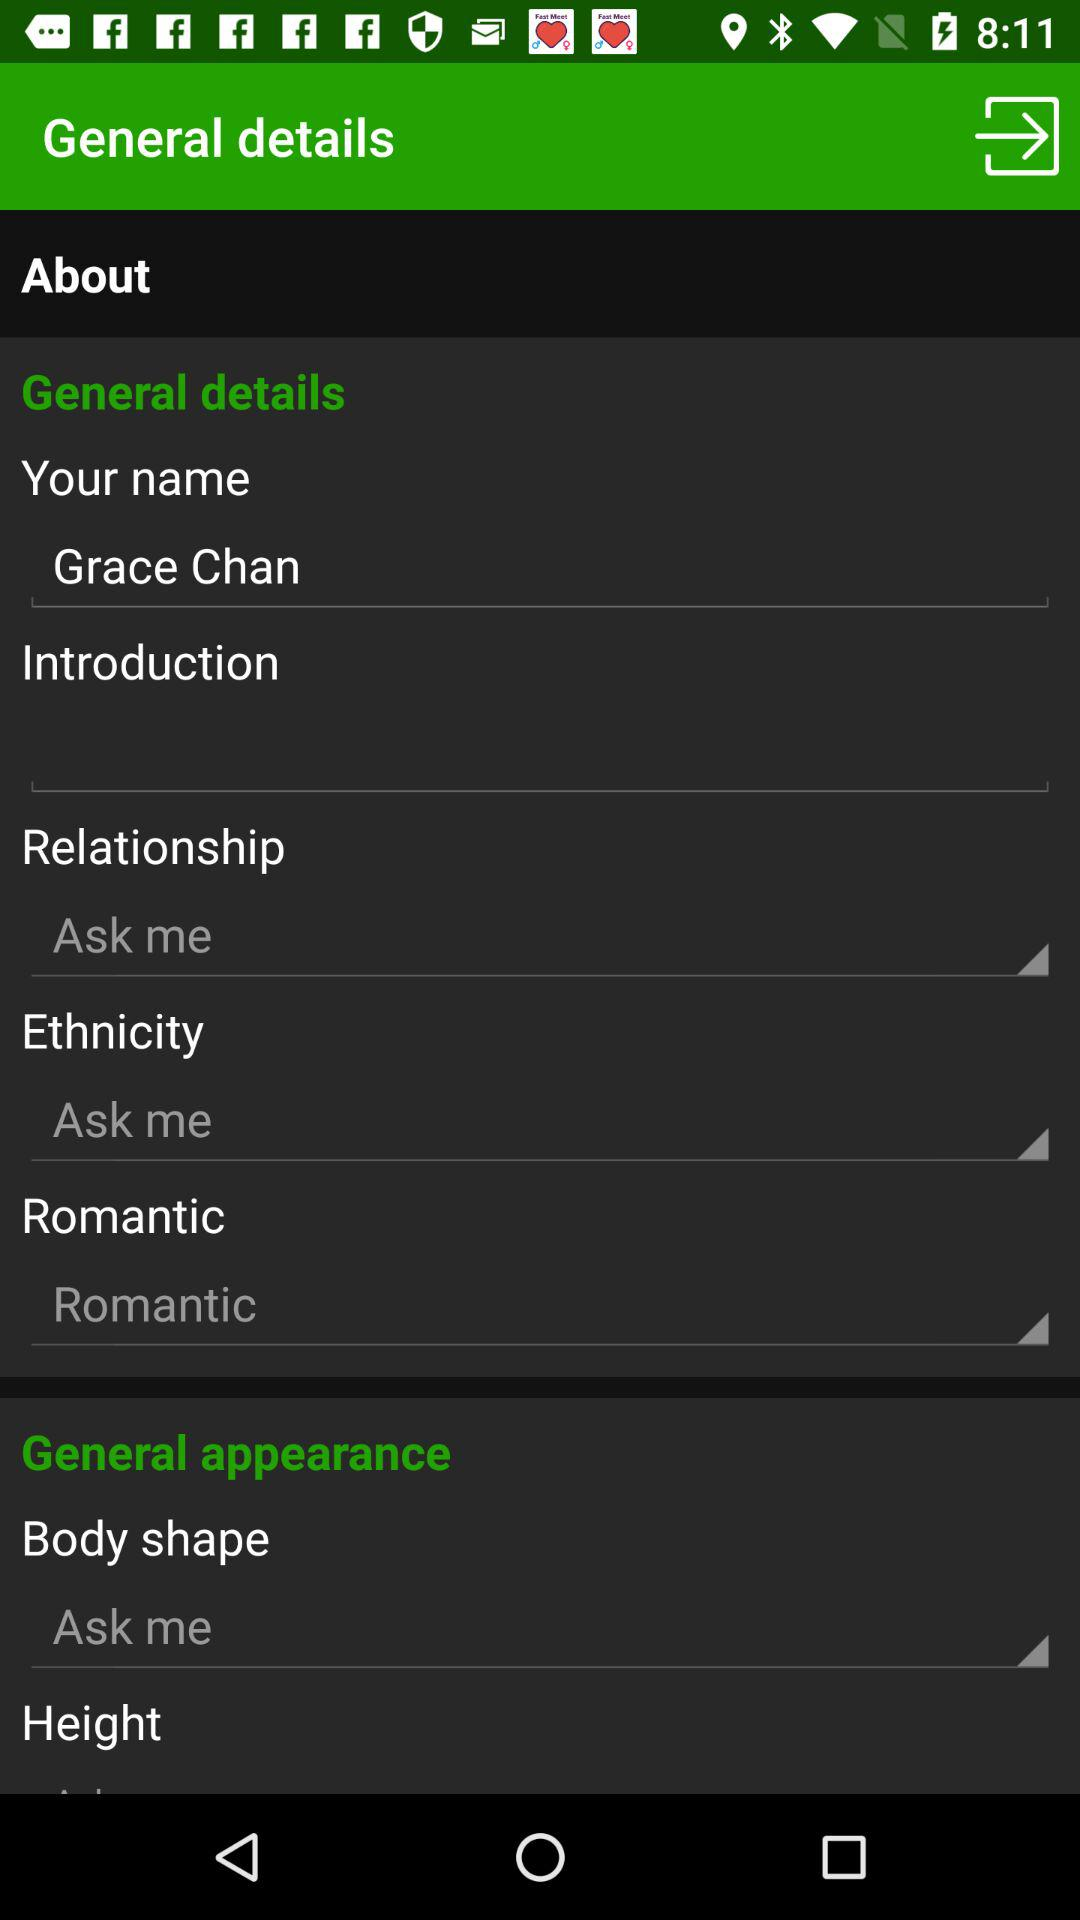What is the relationship status? The relationship status is "Ask me". 